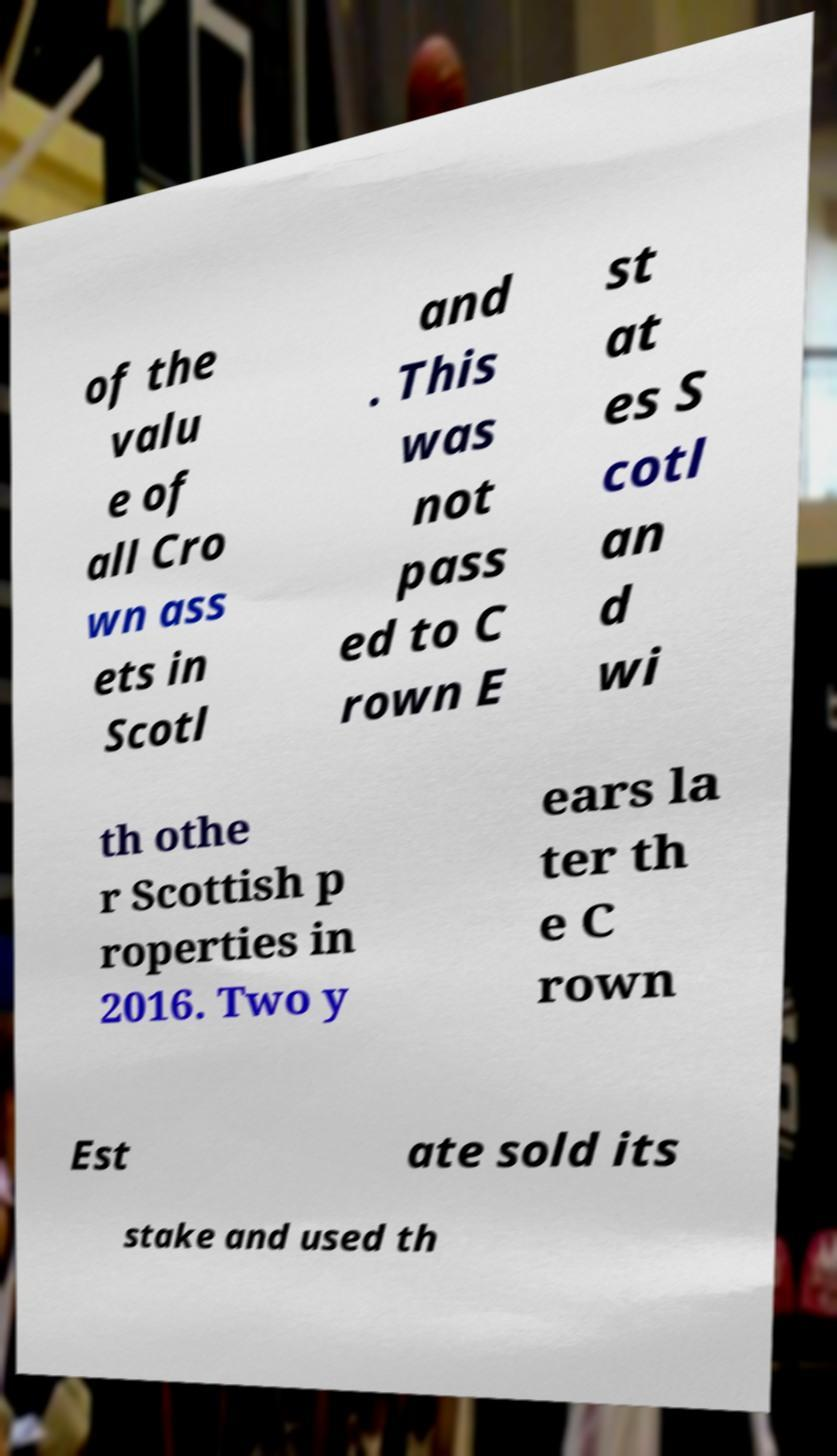For documentation purposes, I need the text within this image transcribed. Could you provide that? of the valu e of all Cro wn ass ets in Scotl and . This was not pass ed to C rown E st at es S cotl an d wi th othe r Scottish p roperties in 2016. Two y ears la ter th e C rown Est ate sold its stake and used th 